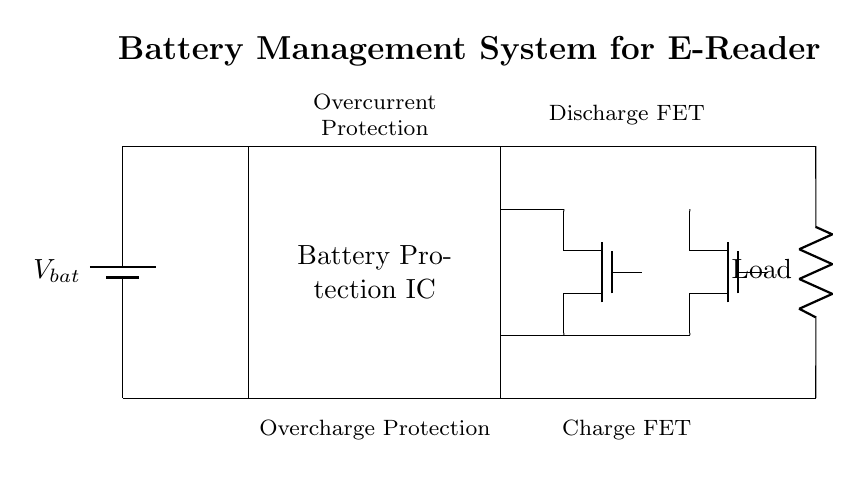What is the type of battery used in this circuit? The circuit diagram does not specify a model or type but indicates a general battery symbol which implies a rechargeable battery used in handheld devices. Common types for e-readers include lithium-ion or lithium-polymer.
Answer: Rechargeable What component protects against overcharging? The circuit states that there is a "Battery Protection IC" which is responsible for monitoring battery state to prevent overcharging. It works in conjunction with the configured MOSFETs.
Answer: Battery Protection IC How many MOSFETs are present in this circuit? The diagram shows two MOSFETs labeled T1 and T2, indicating a strategy for both charging and discharging current paths.
Answer: Two What function does the "Discharge FET" provide? The Discharge FET connected in the circuit provides a controlled path for current to flow to the load during discharge, ensuring that the battery does not supply too much current or degrade prematurely during usage.
Answer: Current control What does the term "overcurrent protection" signify in this context? Overcurrent protection refers to the functionality provided by the Battery Protection IC that prevents excessive current from flowing through the circuit, which can lead to overheating or damage to the battery. This is critical for safe operation and longevity.
Answer: Prevents excess current Where do the connections to the "Load" occur in the circuit? The connections to the Load occur at the output of the circuit through the discharge path created by the connections after the MOSFETs. This places the Load in line with the battery when the discharge FET is active.
Answer: Output to Load 